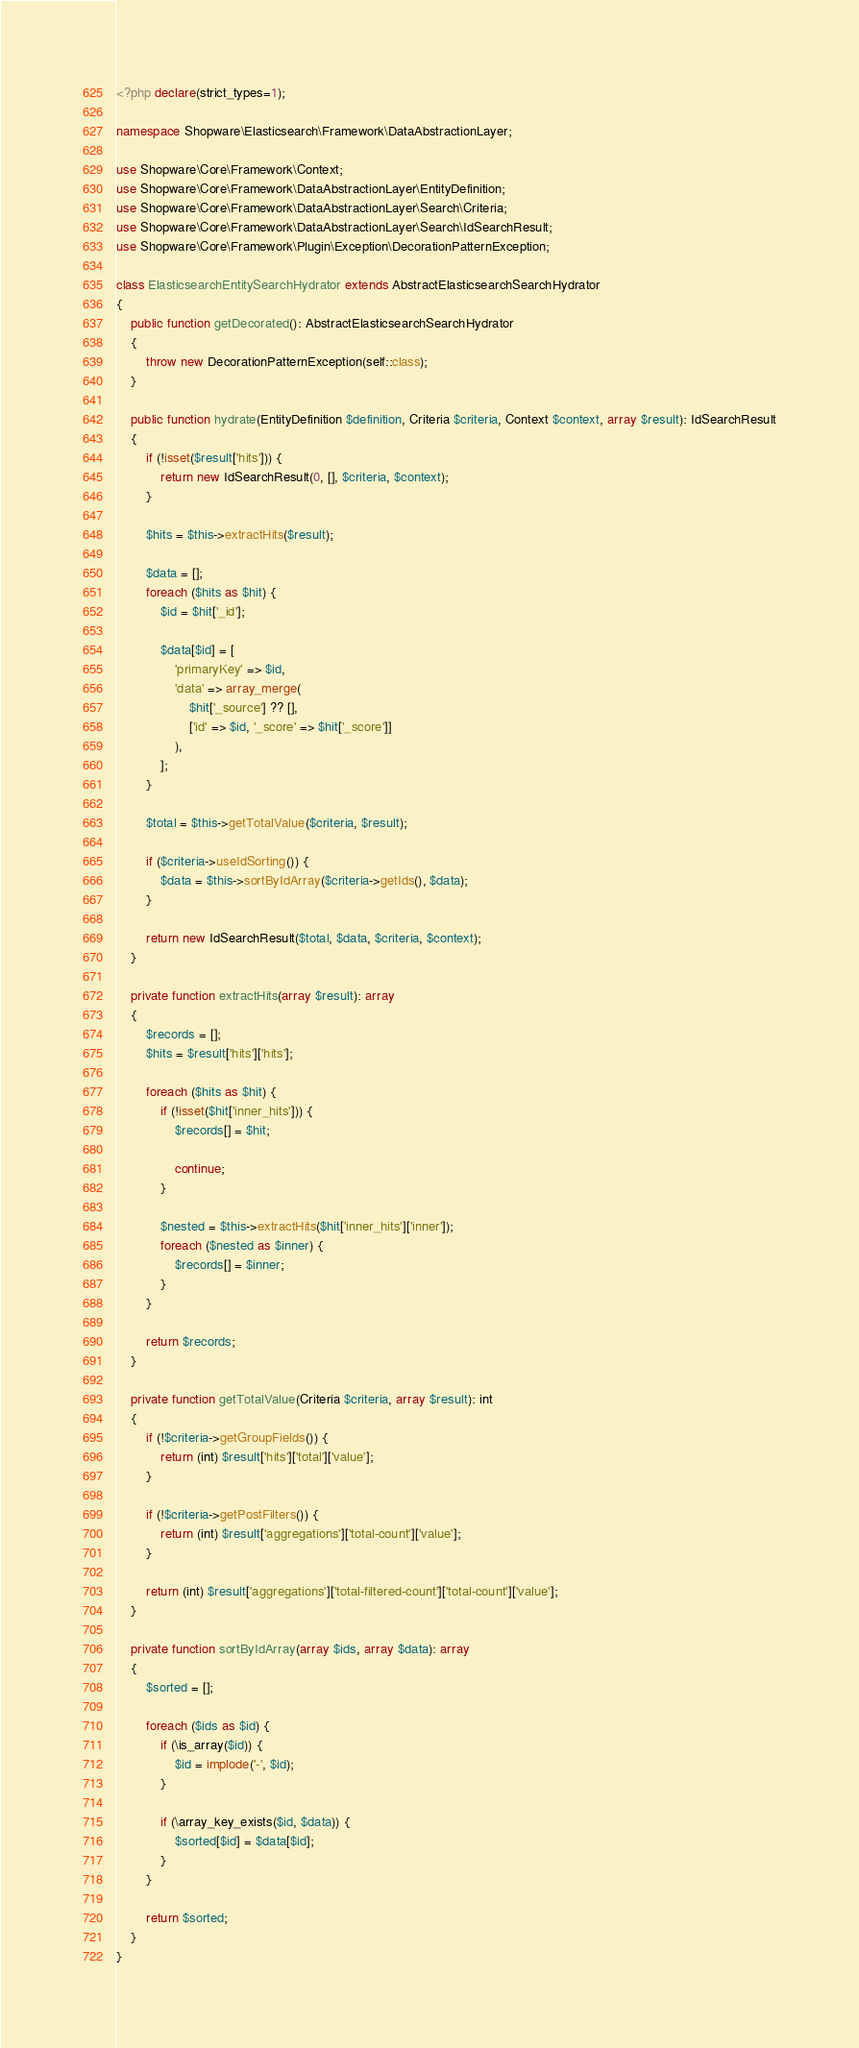<code> <loc_0><loc_0><loc_500><loc_500><_PHP_><?php declare(strict_types=1);

namespace Shopware\Elasticsearch\Framework\DataAbstractionLayer;

use Shopware\Core\Framework\Context;
use Shopware\Core\Framework\DataAbstractionLayer\EntityDefinition;
use Shopware\Core\Framework\DataAbstractionLayer\Search\Criteria;
use Shopware\Core\Framework\DataAbstractionLayer\Search\IdSearchResult;
use Shopware\Core\Framework\Plugin\Exception\DecorationPatternException;

class ElasticsearchEntitySearchHydrator extends AbstractElasticsearchSearchHydrator
{
    public function getDecorated(): AbstractElasticsearchSearchHydrator
    {
        throw new DecorationPatternException(self::class);
    }

    public function hydrate(EntityDefinition $definition, Criteria $criteria, Context $context, array $result): IdSearchResult
    {
        if (!isset($result['hits'])) {
            return new IdSearchResult(0, [], $criteria, $context);
        }

        $hits = $this->extractHits($result);

        $data = [];
        foreach ($hits as $hit) {
            $id = $hit['_id'];

            $data[$id] = [
                'primaryKey' => $id,
                'data' => array_merge(
                    $hit['_source'] ?? [],
                    ['id' => $id, '_score' => $hit['_score']]
                ),
            ];
        }

        $total = $this->getTotalValue($criteria, $result);

        if ($criteria->useIdSorting()) {
            $data = $this->sortByIdArray($criteria->getIds(), $data);
        }

        return new IdSearchResult($total, $data, $criteria, $context);
    }

    private function extractHits(array $result): array
    {
        $records = [];
        $hits = $result['hits']['hits'];

        foreach ($hits as $hit) {
            if (!isset($hit['inner_hits'])) {
                $records[] = $hit;

                continue;
            }

            $nested = $this->extractHits($hit['inner_hits']['inner']);
            foreach ($nested as $inner) {
                $records[] = $inner;
            }
        }

        return $records;
    }

    private function getTotalValue(Criteria $criteria, array $result): int
    {
        if (!$criteria->getGroupFields()) {
            return (int) $result['hits']['total']['value'];
        }

        if (!$criteria->getPostFilters()) {
            return (int) $result['aggregations']['total-count']['value'];
        }

        return (int) $result['aggregations']['total-filtered-count']['total-count']['value'];
    }

    private function sortByIdArray(array $ids, array $data): array
    {
        $sorted = [];

        foreach ($ids as $id) {
            if (\is_array($id)) {
                $id = implode('-', $id);
            }

            if (\array_key_exists($id, $data)) {
                $sorted[$id] = $data[$id];
            }
        }

        return $sorted;
    }
}
</code> 